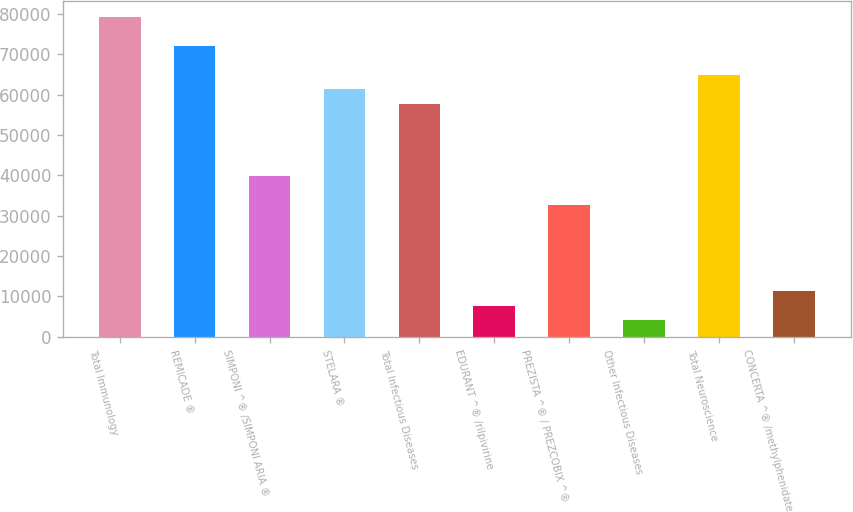<chart> <loc_0><loc_0><loc_500><loc_500><bar_chart><fcel>Total Immunology<fcel>REMICADE ®<fcel>SIMPONI ^® /SIMPONI ARIA ®<fcel>STELARA ®<fcel>Total Infectious Diseases<fcel>EDURANT ^® /rilpivirine<fcel>PREZISTA ^® / PREZCOBIX ^®<fcel>Other Infectious Diseases<fcel>Total Neuroscience<fcel>CONCERTA ^® /methylphenidate<nl><fcel>79158.4<fcel>72008<fcel>39831.2<fcel>61282.4<fcel>57707.2<fcel>7654.4<fcel>32680.8<fcel>4079.2<fcel>64857.6<fcel>11229.6<nl></chart> 